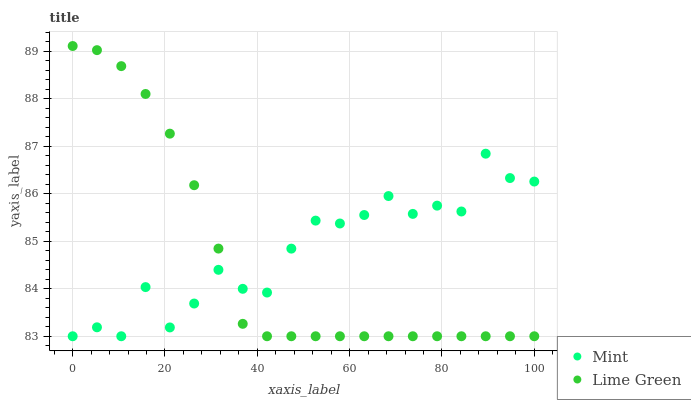Does Lime Green have the minimum area under the curve?
Answer yes or no. Yes. Does Mint have the maximum area under the curve?
Answer yes or no. Yes. Does Mint have the minimum area under the curve?
Answer yes or no. No. Is Lime Green the smoothest?
Answer yes or no. Yes. Is Mint the roughest?
Answer yes or no. Yes. Is Mint the smoothest?
Answer yes or no. No. Does Lime Green have the lowest value?
Answer yes or no. Yes. Does Lime Green have the highest value?
Answer yes or no. Yes. Does Mint have the highest value?
Answer yes or no. No. Does Mint intersect Lime Green?
Answer yes or no. Yes. Is Mint less than Lime Green?
Answer yes or no. No. Is Mint greater than Lime Green?
Answer yes or no. No. 